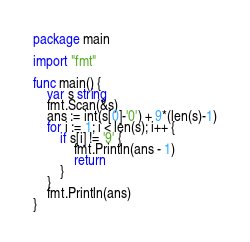Convert code to text. <code><loc_0><loc_0><loc_500><loc_500><_Go_>package main

import "fmt"

func main() {
	var s string
	fmt.Scan(&s)
	ans := int(s[0]-'0') + 9*(len(s)-1)
	for i := 1; i < len(s); i++ {
		if s[i] != '9' {
			fmt.Println(ans - 1)
			return
		}
	}
	fmt.Println(ans)
}
</code> 